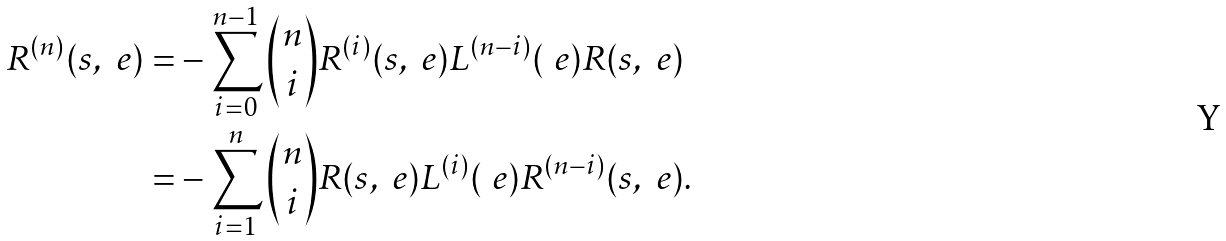Convert formula to latex. <formula><loc_0><loc_0><loc_500><loc_500>R ^ { ( n ) } ( s , \ e ) = & - \sum _ { i = 0 } ^ { n - 1 } \binom { n } { i } R ^ { ( i ) } ( s , \ e ) L ^ { ( n - i ) } ( \ e ) R ( s , \ e ) \\ = & - \sum _ { i = 1 } ^ { n } \binom { n } { i } R ( s , \ e ) L ^ { ( i ) } ( \ e ) R ^ { ( n - i ) } ( s , \ e ) .</formula> 